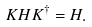<formula> <loc_0><loc_0><loc_500><loc_500>K H K ^ { \dagger } = H .</formula> 